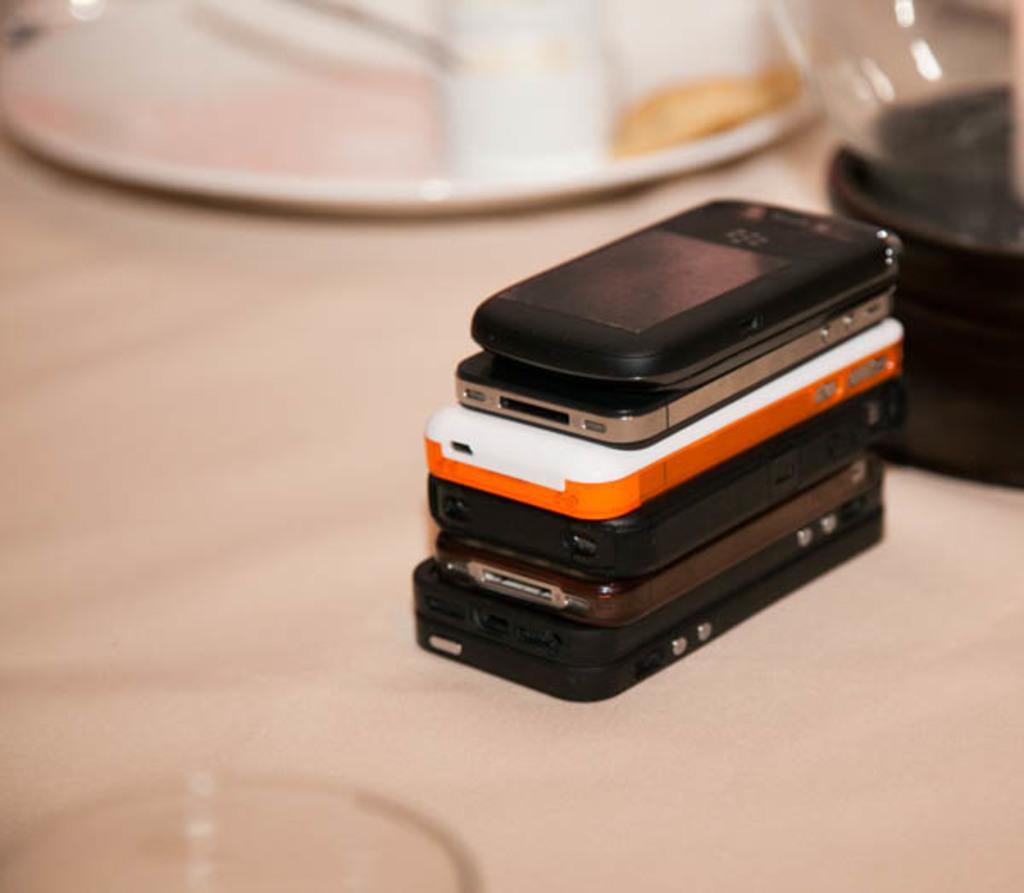Please provide a concise description of this image. In this picture we can see few mobiles, plate and other things on the table. 